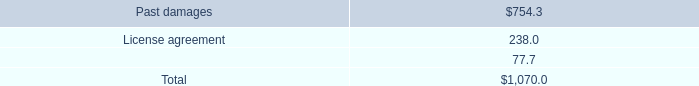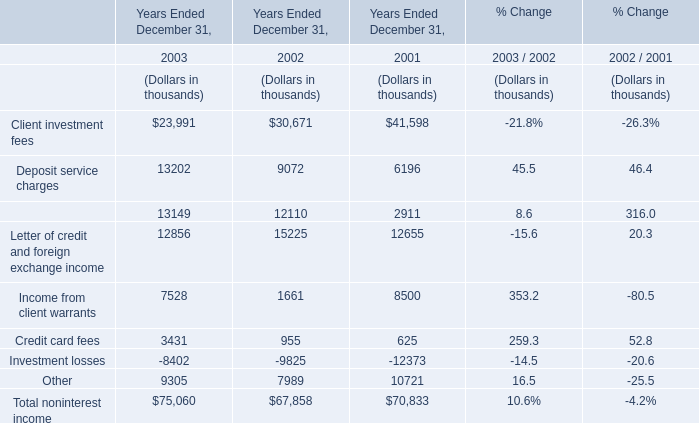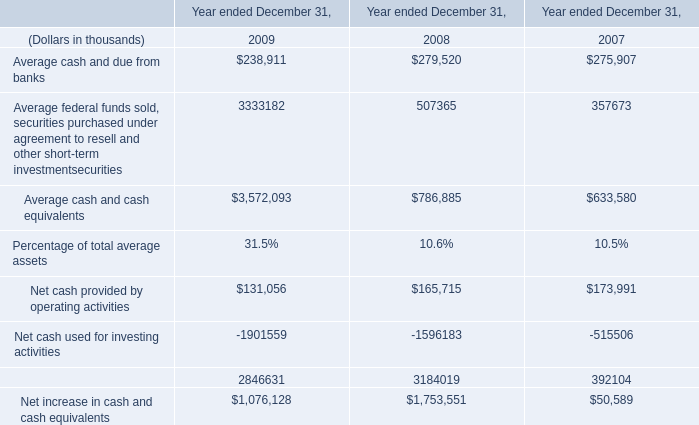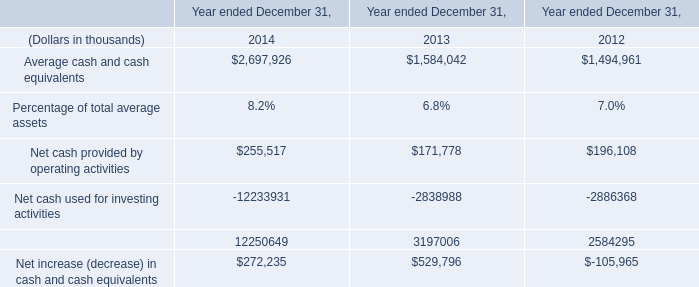What's the increasing rate of Corporate finance fees in 2003? 
Computations: ((13149 - 12110) / 12110)
Answer: 0.0858. 